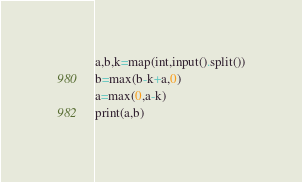<code> <loc_0><loc_0><loc_500><loc_500><_Python_>a,b,k=map(int,input().split())
b=max(b-k+a,0)
a=max(0,a-k)
print(a,b)</code> 